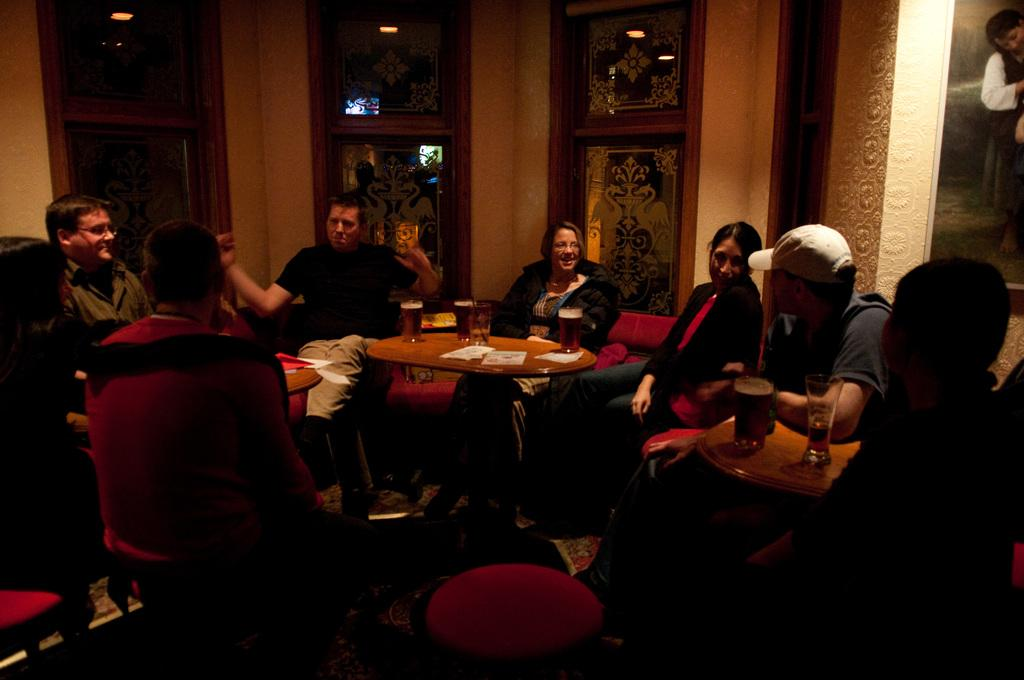What are the people in the image doing? The people in the image are sitting on chairs. What is the main piece of furniture in the image? There is a table in the image. What objects can be seen on the table? There are glasses on the table. Reasoning: Let' Let's think step by step in order to produce the conversation. We start by identifying the main subjects in the image, which are the people sitting on chairs. Then, we describe the main piece of furniture, which is the table. Finally, we mention the objects on the table, which are glasses. Each question is designed to elicit a specific detail about the image that is known from the provided facts. Absurd Question/Answer: How many knots are tied on the chairs in the image? There are no knots present in the image, as the chairs are not tied with any ropes or strings. How many whips can be seen on the table in the image? There are no whips present in the image; the objects on the table are glasses. --- Facts: 1. There is a car in the image. 2. The car is red. 3. The car has four wheels. 4. There is a road in the image. 5. The car is parked on the side of the road. Absurd Topics: unicorn, rainbow, parrot Conversation: What is the main subject in the image? There is a car in the image. What color is the car? The car is red. How many wheels does the car have? The car has four wheels. What is the background of the image? There is a road in the image. How is the car positioned in the image? The car is parked on the side of the road. Reasoning: Let's think step by step in order to produce the conversation. We start by identifying the main subject of the image, which is the car. Next, we describe specific features of the car, such as the color and the number of wheels. Then, we observe the background of the image, which is a road. Finally, we describe the position of the car in the image, which is 